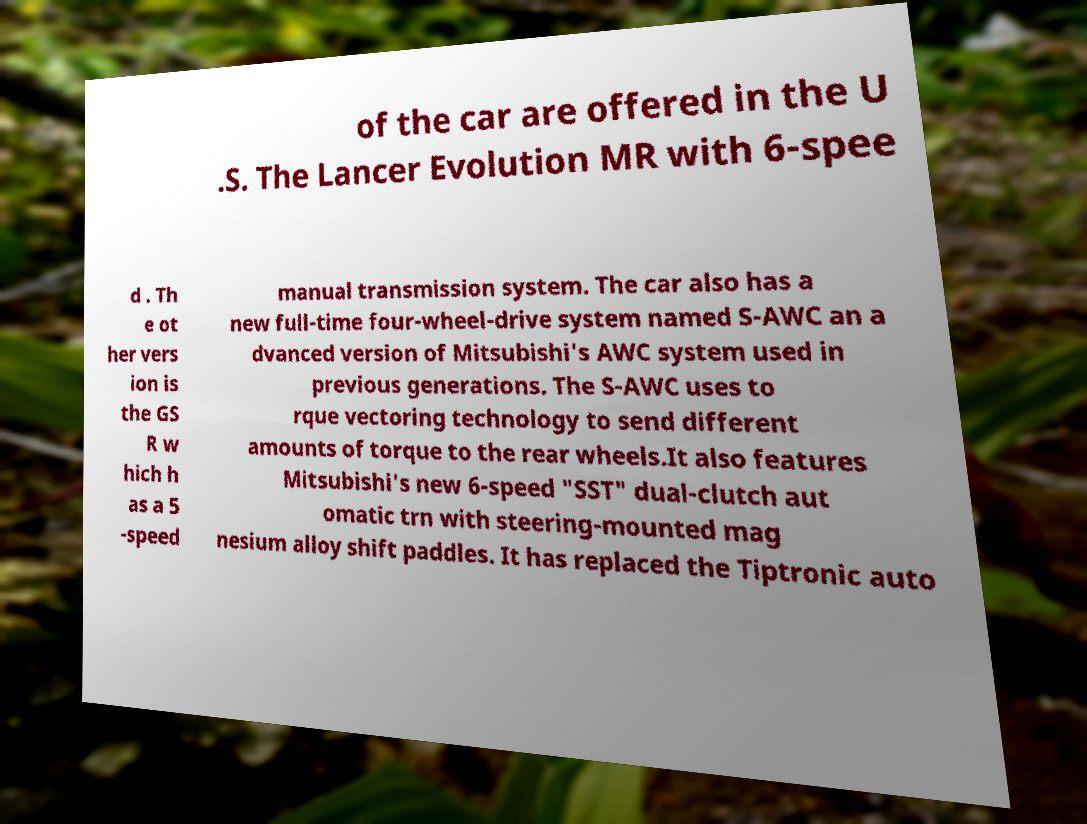Please identify and transcribe the text found in this image. of the car are offered in the U .S. The Lancer Evolution MR with 6-spee d . Th e ot her vers ion is the GS R w hich h as a 5 -speed manual transmission system. The car also has a new full-time four-wheel-drive system named S-AWC an a dvanced version of Mitsubishi's AWC system used in previous generations. The S-AWC uses to rque vectoring technology to send different amounts of torque to the rear wheels.It also features Mitsubishi's new 6-speed "SST" dual-clutch aut omatic trn with steering-mounted mag nesium alloy shift paddles. It has replaced the Tiptronic auto 